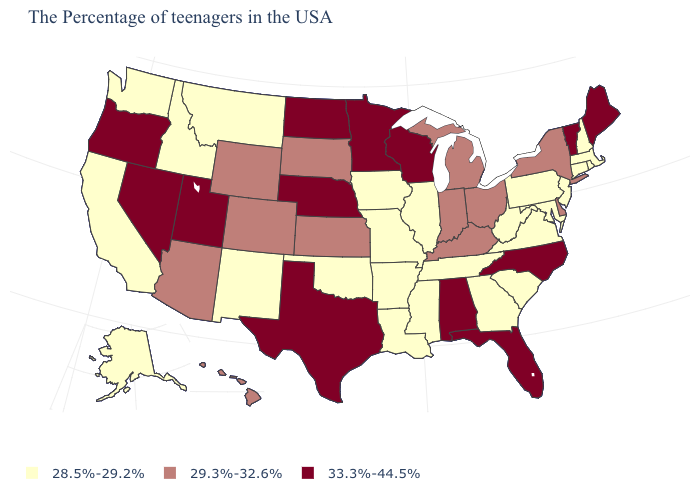Does Florida have the highest value in the USA?
Quick response, please. Yes. Name the states that have a value in the range 28.5%-29.2%?
Give a very brief answer. Massachusetts, Rhode Island, New Hampshire, Connecticut, New Jersey, Maryland, Pennsylvania, Virginia, South Carolina, West Virginia, Georgia, Tennessee, Illinois, Mississippi, Louisiana, Missouri, Arkansas, Iowa, Oklahoma, New Mexico, Montana, Idaho, California, Washington, Alaska. What is the value of Oklahoma?
Write a very short answer. 28.5%-29.2%. What is the value of North Dakota?
Give a very brief answer. 33.3%-44.5%. Does Nevada have the lowest value in the West?
Write a very short answer. No. Among the states that border Mississippi , does Alabama have the lowest value?
Quick response, please. No. Does Oregon have the highest value in the West?
Quick response, please. Yes. Does Missouri have the lowest value in the USA?
Short answer required. Yes. Which states have the lowest value in the USA?
Short answer required. Massachusetts, Rhode Island, New Hampshire, Connecticut, New Jersey, Maryland, Pennsylvania, Virginia, South Carolina, West Virginia, Georgia, Tennessee, Illinois, Mississippi, Louisiana, Missouri, Arkansas, Iowa, Oklahoma, New Mexico, Montana, Idaho, California, Washington, Alaska. Does Nebraska have the highest value in the MidWest?
Concise answer only. Yes. Does the first symbol in the legend represent the smallest category?
Answer briefly. Yes. What is the highest value in the USA?
Give a very brief answer. 33.3%-44.5%. Name the states that have a value in the range 29.3%-32.6%?
Be succinct. New York, Delaware, Ohio, Michigan, Kentucky, Indiana, Kansas, South Dakota, Wyoming, Colorado, Arizona, Hawaii. Which states have the lowest value in the USA?
Quick response, please. Massachusetts, Rhode Island, New Hampshire, Connecticut, New Jersey, Maryland, Pennsylvania, Virginia, South Carolina, West Virginia, Georgia, Tennessee, Illinois, Mississippi, Louisiana, Missouri, Arkansas, Iowa, Oklahoma, New Mexico, Montana, Idaho, California, Washington, Alaska. What is the highest value in the MidWest ?
Answer briefly. 33.3%-44.5%. 